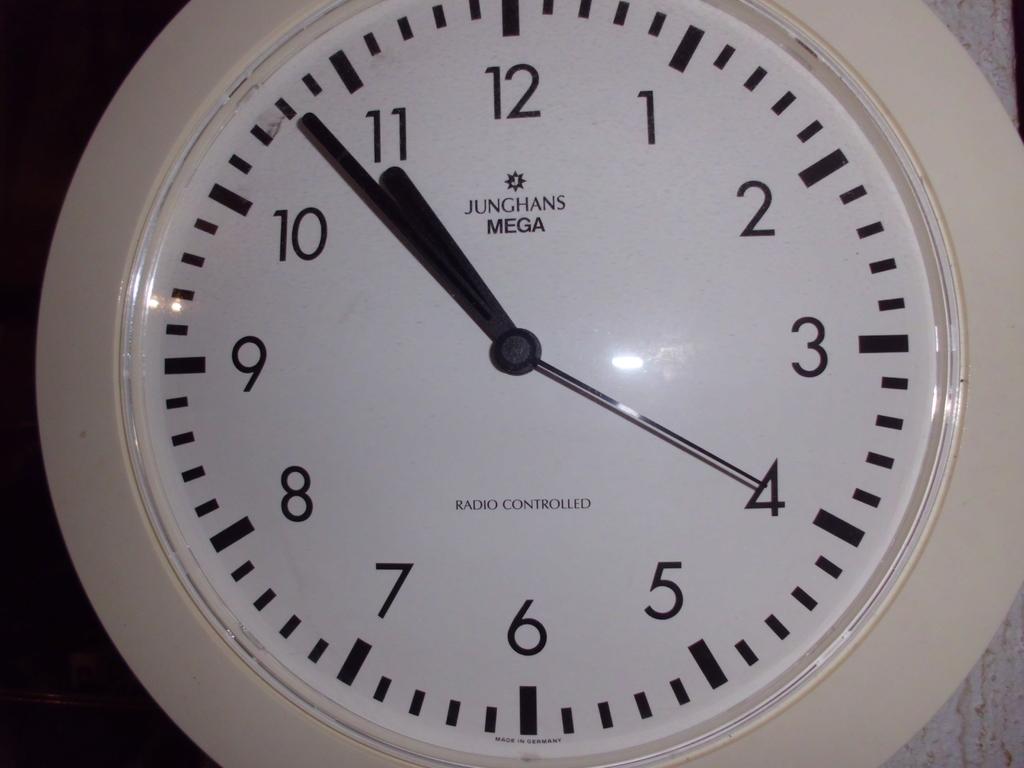What brand is the clock?
Offer a terse response. Junghans. 